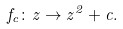<formula> <loc_0><loc_0><loc_500><loc_500>f _ { c } \colon z \to z ^ { 2 } + c .</formula> 